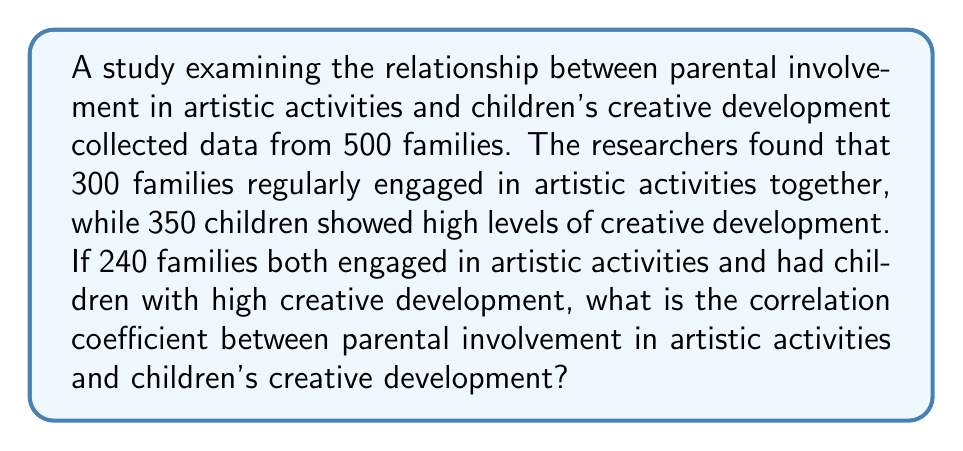Provide a solution to this math problem. To calculate the correlation coefficient, we'll use the phi coefficient, which is suitable for dichotomous variables. Let's follow these steps:

1. Create a 2x2 contingency table:
   $$\begin{array}{c|c|c|c}
   & \text{High Creativity} & \text{Low Creativity} & \text{Total} \\
   \hline
   \text{Artistic Involvement} & 240 & 60 & 300 \\
   \text{No Artistic Involvement} & 110 & 90 & 200 \\
   \hline
   \text{Total} & 350 & 150 & 500
   \end{array}$$

2. Use the phi coefficient formula:
   $$\phi = \frac{ad - bc}{\sqrt{(a+b)(c+d)(a+c)(b+d)}}$$
   
   Where:
   $a = 240$ (Artistic Involvement and High Creativity)
   $b = 60$ (Artistic Involvement and Low Creativity)
   $c = 110$ (No Artistic Involvement and High Creativity)
   $d = 90$ (No Artistic Involvement and Low Creativity)

3. Plug in the values:
   $$\phi = \frac{240 \times 90 - 60 \times 110}{\sqrt{300 \times 200 \times 350 \times 150}}$$

4. Calculate:
   $$\phi = \frac{21600 - 6600}{\sqrt{3150000000}}$$
   $$\phi = \frac{15000}{56125}$$
   $$\phi \approx 0.2672$$

The correlation coefficient is approximately 0.2672, indicating a weak positive correlation between parental involvement in artistic activities and children's creative development.
Answer: 0.2672 